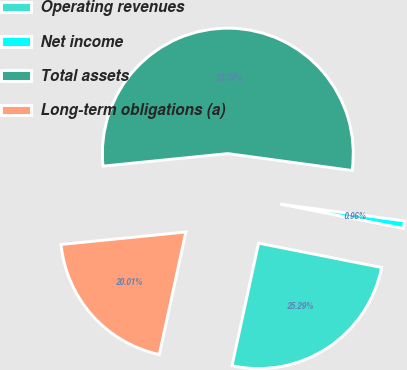<chart> <loc_0><loc_0><loc_500><loc_500><pie_chart><fcel>Operating revenues<fcel>Net income<fcel>Total assets<fcel>Long-term obligations (a)<nl><fcel>25.29%<fcel>0.96%<fcel>53.74%<fcel>20.01%<nl></chart> 